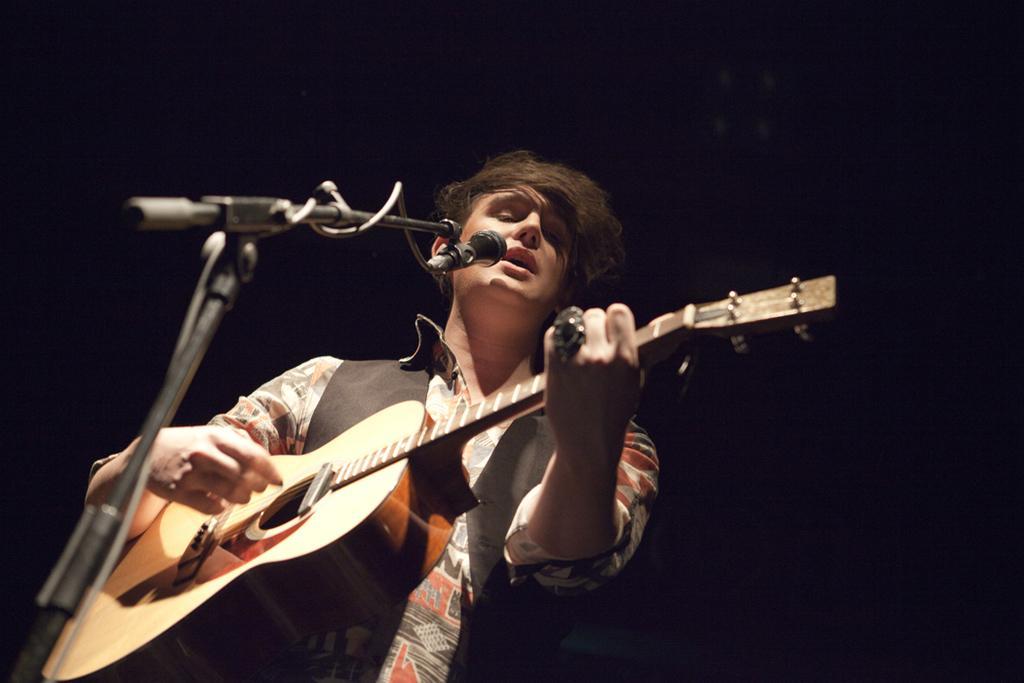Can you describe this image briefly? In this image i can see a person holding a guitar and there is a microphone in front of him. 